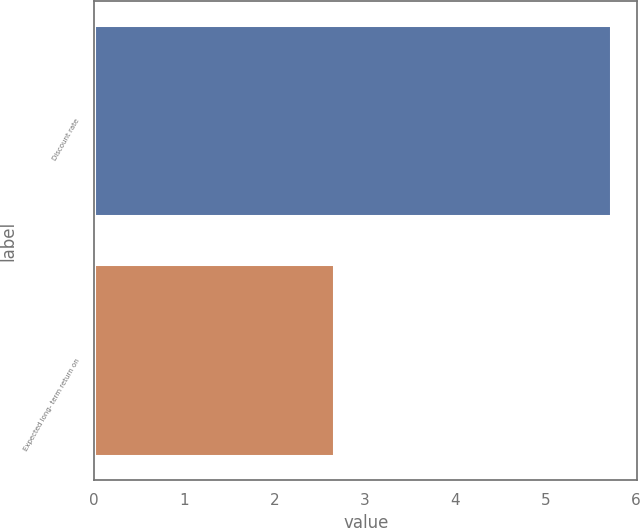<chart> <loc_0><loc_0><loc_500><loc_500><bar_chart><fcel>Discount rate<fcel>Expected long- term return on<nl><fcel>5.73<fcel>2.66<nl></chart> 